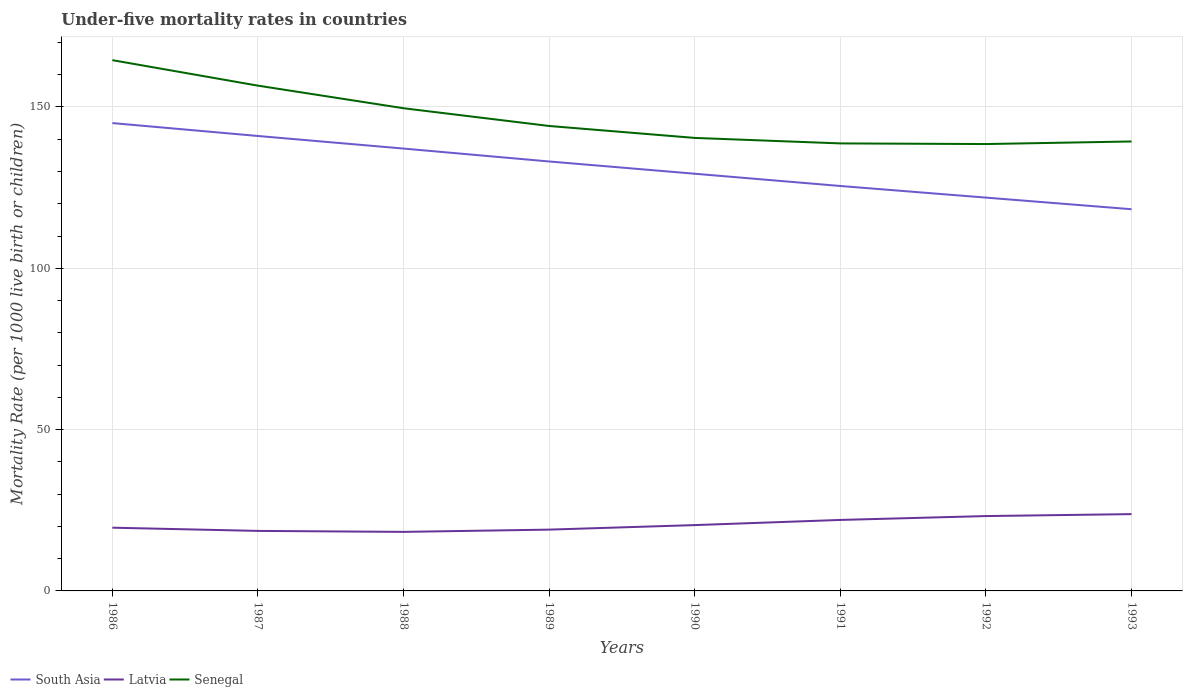How many different coloured lines are there?
Your answer should be very brief. 3. Across all years, what is the maximum under-five mortality rate in Senegal?
Offer a terse response. 138.5. In which year was the under-five mortality rate in Latvia maximum?
Your answer should be compact. 1988. What is the total under-five mortality rate in Senegal in the graph?
Offer a very short reply. 0.2. What is the difference between the highest and the second highest under-five mortality rate in South Asia?
Give a very brief answer. 26.7. How many lines are there?
Your answer should be very brief. 3. How many years are there in the graph?
Your answer should be compact. 8. What is the difference between two consecutive major ticks on the Y-axis?
Keep it short and to the point. 50. Are the values on the major ticks of Y-axis written in scientific E-notation?
Ensure brevity in your answer.  No. Does the graph contain any zero values?
Keep it short and to the point. No. Where does the legend appear in the graph?
Make the answer very short. Bottom left. What is the title of the graph?
Make the answer very short. Under-five mortality rates in countries. Does "Suriname" appear as one of the legend labels in the graph?
Your response must be concise. No. What is the label or title of the Y-axis?
Your answer should be compact. Mortality Rate (per 1000 live birth or children). What is the Mortality Rate (per 1000 live birth or children) in South Asia in 1986?
Your response must be concise. 145. What is the Mortality Rate (per 1000 live birth or children) in Latvia in 1986?
Your response must be concise. 19.6. What is the Mortality Rate (per 1000 live birth or children) in Senegal in 1986?
Keep it short and to the point. 164.5. What is the Mortality Rate (per 1000 live birth or children) of South Asia in 1987?
Keep it short and to the point. 141. What is the Mortality Rate (per 1000 live birth or children) in Latvia in 1987?
Ensure brevity in your answer.  18.6. What is the Mortality Rate (per 1000 live birth or children) of Senegal in 1987?
Offer a terse response. 156.6. What is the Mortality Rate (per 1000 live birth or children) of South Asia in 1988?
Keep it short and to the point. 137.1. What is the Mortality Rate (per 1000 live birth or children) of Latvia in 1988?
Make the answer very short. 18.3. What is the Mortality Rate (per 1000 live birth or children) in Senegal in 1988?
Offer a terse response. 149.6. What is the Mortality Rate (per 1000 live birth or children) of South Asia in 1989?
Ensure brevity in your answer.  133.1. What is the Mortality Rate (per 1000 live birth or children) of Latvia in 1989?
Keep it short and to the point. 19. What is the Mortality Rate (per 1000 live birth or children) in Senegal in 1989?
Your response must be concise. 144.1. What is the Mortality Rate (per 1000 live birth or children) of South Asia in 1990?
Offer a terse response. 129.3. What is the Mortality Rate (per 1000 live birth or children) in Latvia in 1990?
Your answer should be compact. 20.4. What is the Mortality Rate (per 1000 live birth or children) in Senegal in 1990?
Give a very brief answer. 140.4. What is the Mortality Rate (per 1000 live birth or children) in South Asia in 1991?
Your answer should be compact. 125.5. What is the Mortality Rate (per 1000 live birth or children) of Latvia in 1991?
Your answer should be compact. 22. What is the Mortality Rate (per 1000 live birth or children) in Senegal in 1991?
Keep it short and to the point. 138.7. What is the Mortality Rate (per 1000 live birth or children) of South Asia in 1992?
Provide a short and direct response. 121.9. What is the Mortality Rate (per 1000 live birth or children) in Latvia in 1992?
Your answer should be compact. 23.2. What is the Mortality Rate (per 1000 live birth or children) of Senegal in 1992?
Give a very brief answer. 138.5. What is the Mortality Rate (per 1000 live birth or children) in South Asia in 1993?
Your answer should be very brief. 118.3. What is the Mortality Rate (per 1000 live birth or children) of Latvia in 1993?
Your answer should be very brief. 23.8. What is the Mortality Rate (per 1000 live birth or children) of Senegal in 1993?
Give a very brief answer. 139.3. Across all years, what is the maximum Mortality Rate (per 1000 live birth or children) of South Asia?
Make the answer very short. 145. Across all years, what is the maximum Mortality Rate (per 1000 live birth or children) in Latvia?
Provide a short and direct response. 23.8. Across all years, what is the maximum Mortality Rate (per 1000 live birth or children) in Senegal?
Ensure brevity in your answer.  164.5. Across all years, what is the minimum Mortality Rate (per 1000 live birth or children) in South Asia?
Give a very brief answer. 118.3. Across all years, what is the minimum Mortality Rate (per 1000 live birth or children) of Senegal?
Your answer should be compact. 138.5. What is the total Mortality Rate (per 1000 live birth or children) of South Asia in the graph?
Ensure brevity in your answer.  1051.2. What is the total Mortality Rate (per 1000 live birth or children) of Latvia in the graph?
Keep it short and to the point. 164.9. What is the total Mortality Rate (per 1000 live birth or children) in Senegal in the graph?
Provide a short and direct response. 1171.7. What is the difference between the Mortality Rate (per 1000 live birth or children) of Latvia in 1986 and that in 1987?
Provide a succinct answer. 1. What is the difference between the Mortality Rate (per 1000 live birth or children) in Senegal in 1986 and that in 1988?
Provide a succinct answer. 14.9. What is the difference between the Mortality Rate (per 1000 live birth or children) of South Asia in 1986 and that in 1989?
Your response must be concise. 11.9. What is the difference between the Mortality Rate (per 1000 live birth or children) in Latvia in 1986 and that in 1989?
Ensure brevity in your answer.  0.6. What is the difference between the Mortality Rate (per 1000 live birth or children) in Senegal in 1986 and that in 1989?
Your answer should be compact. 20.4. What is the difference between the Mortality Rate (per 1000 live birth or children) of South Asia in 1986 and that in 1990?
Offer a very short reply. 15.7. What is the difference between the Mortality Rate (per 1000 live birth or children) of Senegal in 1986 and that in 1990?
Provide a short and direct response. 24.1. What is the difference between the Mortality Rate (per 1000 live birth or children) of Latvia in 1986 and that in 1991?
Give a very brief answer. -2.4. What is the difference between the Mortality Rate (per 1000 live birth or children) of Senegal in 1986 and that in 1991?
Make the answer very short. 25.8. What is the difference between the Mortality Rate (per 1000 live birth or children) in South Asia in 1986 and that in 1992?
Give a very brief answer. 23.1. What is the difference between the Mortality Rate (per 1000 live birth or children) of Latvia in 1986 and that in 1992?
Offer a very short reply. -3.6. What is the difference between the Mortality Rate (per 1000 live birth or children) in Senegal in 1986 and that in 1992?
Keep it short and to the point. 26. What is the difference between the Mortality Rate (per 1000 live birth or children) in South Asia in 1986 and that in 1993?
Your response must be concise. 26.7. What is the difference between the Mortality Rate (per 1000 live birth or children) in Senegal in 1986 and that in 1993?
Provide a succinct answer. 25.2. What is the difference between the Mortality Rate (per 1000 live birth or children) of South Asia in 1987 and that in 1988?
Keep it short and to the point. 3.9. What is the difference between the Mortality Rate (per 1000 live birth or children) in Senegal in 1987 and that in 1989?
Provide a succinct answer. 12.5. What is the difference between the Mortality Rate (per 1000 live birth or children) of Latvia in 1987 and that in 1990?
Offer a very short reply. -1.8. What is the difference between the Mortality Rate (per 1000 live birth or children) of Latvia in 1987 and that in 1991?
Your answer should be very brief. -3.4. What is the difference between the Mortality Rate (per 1000 live birth or children) of Latvia in 1987 and that in 1992?
Provide a succinct answer. -4.6. What is the difference between the Mortality Rate (per 1000 live birth or children) of South Asia in 1987 and that in 1993?
Offer a very short reply. 22.7. What is the difference between the Mortality Rate (per 1000 live birth or children) in Latvia in 1987 and that in 1993?
Provide a short and direct response. -5.2. What is the difference between the Mortality Rate (per 1000 live birth or children) of Senegal in 1987 and that in 1993?
Offer a terse response. 17.3. What is the difference between the Mortality Rate (per 1000 live birth or children) in South Asia in 1988 and that in 1989?
Offer a very short reply. 4. What is the difference between the Mortality Rate (per 1000 live birth or children) of Senegal in 1988 and that in 1989?
Offer a terse response. 5.5. What is the difference between the Mortality Rate (per 1000 live birth or children) in Latvia in 1988 and that in 1990?
Offer a very short reply. -2.1. What is the difference between the Mortality Rate (per 1000 live birth or children) of South Asia in 1988 and that in 1991?
Provide a short and direct response. 11.6. What is the difference between the Mortality Rate (per 1000 live birth or children) in Senegal in 1988 and that in 1991?
Give a very brief answer. 10.9. What is the difference between the Mortality Rate (per 1000 live birth or children) of South Asia in 1988 and that in 1992?
Offer a terse response. 15.2. What is the difference between the Mortality Rate (per 1000 live birth or children) of South Asia in 1988 and that in 1993?
Provide a short and direct response. 18.8. What is the difference between the Mortality Rate (per 1000 live birth or children) of Latvia in 1988 and that in 1993?
Make the answer very short. -5.5. What is the difference between the Mortality Rate (per 1000 live birth or children) in South Asia in 1989 and that in 1990?
Your answer should be compact. 3.8. What is the difference between the Mortality Rate (per 1000 live birth or children) in Latvia in 1989 and that in 1991?
Offer a terse response. -3. What is the difference between the Mortality Rate (per 1000 live birth or children) in Senegal in 1989 and that in 1991?
Make the answer very short. 5.4. What is the difference between the Mortality Rate (per 1000 live birth or children) in South Asia in 1989 and that in 1992?
Your answer should be compact. 11.2. What is the difference between the Mortality Rate (per 1000 live birth or children) in Senegal in 1989 and that in 1992?
Provide a succinct answer. 5.6. What is the difference between the Mortality Rate (per 1000 live birth or children) of Latvia in 1989 and that in 1993?
Provide a short and direct response. -4.8. What is the difference between the Mortality Rate (per 1000 live birth or children) of Senegal in 1989 and that in 1993?
Give a very brief answer. 4.8. What is the difference between the Mortality Rate (per 1000 live birth or children) of Latvia in 1990 and that in 1991?
Offer a very short reply. -1.6. What is the difference between the Mortality Rate (per 1000 live birth or children) in Senegal in 1990 and that in 1991?
Offer a terse response. 1.7. What is the difference between the Mortality Rate (per 1000 live birth or children) of Latvia in 1990 and that in 1992?
Your answer should be compact. -2.8. What is the difference between the Mortality Rate (per 1000 live birth or children) in Senegal in 1990 and that in 1992?
Your answer should be very brief. 1.9. What is the difference between the Mortality Rate (per 1000 live birth or children) in South Asia in 1990 and that in 1993?
Ensure brevity in your answer.  11. What is the difference between the Mortality Rate (per 1000 live birth or children) of Senegal in 1990 and that in 1993?
Your answer should be compact. 1.1. What is the difference between the Mortality Rate (per 1000 live birth or children) in South Asia in 1991 and that in 1993?
Your answer should be compact. 7.2. What is the difference between the Mortality Rate (per 1000 live birth or children) in Senegal in 1991 and that in 1993?
Provide a short and direct response. -0.6. What is the difference between the Mortality Rate (per 1000 live birth or children) in South Asia in 1992 and that in 1993?
Offer a very short reply. 3.6. What is the difference between the Mortality Rate (per 1000 live birth or children) of Latvia in 1992 and that in 1993?
Your answer should be very brief. -0.6. What is the difference between the Mortality Rate (per 1000 live birth or children) of Senegal in 1992 and that in 1993?
Offer a terse response. -0.8. What is the difference between the Mortality Rate (per 1000 live birth or children) of South Asia in 1986 and the Mortality Rate (per 1000 live birth or children) of Latvia in 1987?
Provide a short and direct response. 126.4. What is the difference between the Mortality Rate (per 1000 live birth or children) of Latvia in 1986 and the Mortality Rate (per 1000 live birth or children) of Senegal in 1987?
Offer a very short reply. -137. What is the difference between the Mortality Rate (per 1000 live birth or children) of South Asia in 1986 and the Mortality Rate (per 1000 live birth or children) of Latvia in 1988?
Offer a terse response. 126.7. What is the difference between the Mortality Rate (per 1000 live birth or children) of South Asia in 1986 and the Mortality Rate (per 1000 live birth or children) of Senegal in 1988?
Ensure brevity in your answer.  -4.6. What is the difference between the Mortality Rate (per 1000 live birth or children) of Latvia in 1986 and the Mortality Rate (per 1000 live birth or children) of Senegal in 1988?
Offer a very short reply. -130. What is the difference between the Mortality Rate (per 1000 live birth or children) of South Asia in 1986 and the Mortality Rate (per 1000 live birth or children) of Latvia in 1989?
Offer a terse response. 126. What is the difference between the Mortality Rate (per 1000 live birth or children) in South Asia in 1986 and the Mortality Rate (per 1000 live birth or children) in Senegal in 1989?
Offer a very short reply. 0.9. What is the difference between the Mortality Rate (per 1000 live birth or children) in Latvia in 1986 and the Mortality Rate (per 1000 live birth or children) in Senegal in 1989?
Give a very brief answer. -124.5. What is the difference between the Mortality Rate (per 1000 live birth or children) of South Asia in 1986 and the Mortality Rate (per 1000 live birth or children) of Latvia in 1990?
Give a very brief answer. 124.6. What is the difference between the Mortality Rate (per 1000 live birth or children) in Latvia in 1986 and the Mortality Rate (per 1000 live birth or children) in Senegal in 1990?
Make the answer very short. -120.8. What is the difference between the Mortality Rate (per 1000 live birth or children) of South Asia in 1986 and the Mortality Rate (per 1000 live birth or children) of Latvia in 1991?
Keep it short and to the point. 123. What is the difference between the Mortality Rate (per 1000 live birth or children) in Latvia in 1986 and the Mortality Rate (per 1000 live birth or children) in Senegal in 1991?
Keep it short and to the point. -119.1. What is the difference between the Mortality Rate (per 1000 live birth or children) of South Asia in 1986 and the Mortality Rate (per 1000 live birth or children) of Latvia in 1992?
Make the answer very short. 121.8. What is the difference between the Mortality Rate (per 1000 live birth or children) in Latvia in 1986 and the Mortality Rate (per 1000 live birth or children) in Senegal in 1992?
Make the answer very short. -118.9. What is the difference between the Mortality Rate (per 1000 live birth or children) in South Asia in 1986 and the Mortality Rate (per 1000 live birth or children) in Latvia in 1993?
Provide a short and direct response. 121.2. What is the difference between the Mortality Rate (per 1000 live birth or children) of Latvia in 1986 and the Mortality Rate (per 1000 live birth or children) of Senegal in 1993?
Your response must be concise. -119.7. What is the difference between the Mortality Rate (per 1000 live birth or children) of South Asia in 1987 and the Mortality Rate (per 1000 live birth or children) of Latvia in 1988?
Provide a succinct answer. 122.7. What is the difference between the Mortality Rate (per 1000 live birth or children) in Latvia in 1987 and the Mortality Rate (per 1000 live birth or children) in Senegal in 1988?
Offer a terse response. -131. What is the difference between the Mortality Rate (per 1000 live birth or children) in South Asia in 1987 and the Mortality Rate (per 1000 live birth or children) in Latvia in 1989?
Give a very brief answer. 122. What is the difference between the Mortality Rate (per 1000 live birth or children) of South Asia in 1987 and the Mortality Rate (per 1000 live birth or children) of Senegal in 1989?
Your answer should be compact. -3.1. What is the difference between the Mortality Rate (per 1000 live birth or children) in Latvia in 1987 and the Mortality Rate (per 1000 live birth or children) in Senegal in 1989?
Provide a short and direct response. -125.5. What is the difference between the Mortality Rate (per 1000 live birth or children) in South Asia in 1987 and the Mortality Rate (per 1000 live birth or children) in Latvia in 1990?
Offer a terse response. 120.6. What is the difference between the Mortality Rate (per 1000 live birth or children) of South Asia in 1987 and the Mortality Rate (per 1000 live birth or children) of Senegal in 1990?
Your response must be concise. 0.6. What is the difference between the Mortality Rate (per 1000 live birth or children) of Latvia in 1987 and the Mortality Rate (per 1000 live birth or children) of Senegal in 1990?
Your response must be concise. -121.8. What is the difference between the Mortality Rate (per 1000 live birth or children) of South Asia in 1987 and the Mortality Rate (per 1000 live birth or children) of Latvia in 1991?
Offer a terse response. 119. What is the difference between the Mortality Rate (per 1000 live birth or children) of Latvia in 1987 and the Mortality Rate (per 1000 live birth or children) of Senegal in 1991?
Offer a terse response. -120.1. What is the difference between the Mortality Rate (per 1000 live birth or children) in South Asia in 1987 and the Mortality Rate (per 1000 live birth or children) in Latvia in 1992?
Offer a terse response. 117.8. What is the difference between the Mortality Rate (per 1000 live birth or children) in South Asia in 1987 and the Mortality Rate (per 1000 live birth or children) in Senegal in 1992?
Give a very brief answer. 2.5. What is the difference between the Mortality Rate (per 1000 live birth or children) of Latvia in 1987 and the Mortality Rate (per 1000 live birth or children) of Senegal in 1992?
Provide a short and direct response. -119.9. What is the difference between the Mortality Rate (per 1000 live birth or children) of South Asia in 1987 and the Mortality Rate (per 1000 live birth or children) of Latvia in 1993?
Offer a terse response. 117.2. What is the difference between the Mortality Rate (per 1000 live birth or children) in South Asia in 1987 and the Mortality Rate (per 1000 live birth or children) in Senegal in 1993?
Make the answer very short. 1.7. What is the difference between the Mortality Rate (per 1000 live birth or children) in Latvia in 1987 and the Mortality Rate (per 1000 live birth or children) in Senegal in 1993?
Provide a short and direct response. -120.7. What is the difference between the Mortality Rate (per 1000 live birth or children) in South Asia in 1988 and the Mortality Rate (per 1000 live birth or children) in Latvia in 1989?
Make the answer very short. 118.1. What is the difference between the Mortality Rate (per 1000 live birth or children) of South Asia in 1988 and the Mortality Rate (per 1000 live birth or children) of Senegal in 1989?
Make the answer very short. -7. What is the difference between the Mortality Rate (per 1000 live birth or children) of Latvia in 1988 and the Mortality Rate (per 1000 live birth or children) of Senegal in 1989?
Provide a short and direct response. -125.8. What is the difference between the Mortality Rate (per 1000 live birth or children) of South Asia in 1988 and the Mortality Rate (per 1000 live birth or children) of Latvia in 1990?
Give a very brief answer. 116.7. What is the difference between the Mortality Rate (per 1000 live birth or children) in South Asia in 1988 and the Mortality Rate (per 1000 live birth or children) in Senegal in 1990?
Your answer should be very brief. -3.3. What is the difference between the Mortality Rate (per 1000 live birth or children) in Latvia in 1988 and the Mortality Rate (per 1000 live birth or children) in Senegal in 1990?
Make the answer very short. -122.1. What is the difference between the Mortality Rate (per 1000 live birth or children) in South Asia in 1988 and the Mortality Rate (per 1000 live birth or children) in Latvia in 1991?
Your answer should be compact. 115.1. What is the difference between the Mortality Rate (per 1000 live birth or children) of South Asia in 1988 and the Mortality Rate (per 1000 live birth or children) of Senegal in 1991?
Keep it short and to the point. -1.6. What is the difference between the Mortality Rate (per 1000 live birth or children) of Latvia in 1988 and the Mortality Rate (per 1000 live birth or children) of Senegal in 1991?
Provide a short and direct response. -120.4. What is the difference between the Mortality Rate (per 1000 live birth or children) in South Asia in 1988 and the Mortality Rate (per 1000 live birth or children) in Latvia in 1992?
Make the answer very short. 113.9. What is the difference between the Mortality Rate (per 1000 live birth or children) of Latvia in 1988 and the Mortality Rate (per 1000 live birth or children) of Senegal in 1992?
Provide a short and direct response. -120.2. What is the difference between the Mortality Rate (per 1000 live birth or children) in South Asia in 1988 and the Mortality Rate (per 1000 live birth or children) in Latvia in 1993?
Your answer should be very brief. 113.3. What is the difference between the Mortality Rate (per 1000 live birth or children) of South Asia in 1988 and the Mortality Rate (per 1000 live birth or children) of Senegal in 1993?
Keep it short and to the point. -2.2. What is the difference between the Mortality Rate (per 1000 live birth or children) in Latvia in 1988 and the Mortality Rate (per 1000 live birth or children) in Senegal in 1993?
Make the answer very short. -121. What is the difference between the Mortality Rate (per 1000 live birth or children) in South Asia in 1989 and the Mortality Rate (per 1000 live birth or children) in Latvia in 1990?
Your answer should be very brief. 112.7. What is the difference between the Mortality Rate (per 1000 live birth or children) in South Asia in 1989 and the Mortality Rate (per 1000 live birth or children) in Senegal in 1990?
Give a very brief answer. -7.3. What is the difference between the Mortality Rate (per 1000 live birth or children) in Latvia in 1989 and the Mortality Rate (per 1000 live birth or children) in Senegal in 1990?
Provide a succinct answer. -121.4. What is the difference between the Mortality Rate (per 1000 live birth or children) of South Asia in 1989 and the Mortality Rate (per 1000 live birth or children) of Latvia in 1991?
Provide a short and direct response. 111.1. What is the difference between the Mortality Rate (per 1000 live birth or children) in South Asia in 1989 and the Mortality Rate (per 1000 live birth or children) in Senegal in 1991?
Make the answer very short. -5.6. What is the difference between the Mortality Rate (per 1000 live birth or children) in Latvia in 1989 and the Mortality Rate (per 1000 live birth or children) in Senegal in 1991?
Give a very brief answer. -119.7. What is the difference between the Mortality Rate (per 1000 live birth or children) of South Asia in 1989 and the Mortality Rate (per 1000 live birth or children) of Latvia in 1992?
Ensure brevity in your answer.  109.9. What is the difference between the Mortality Rate (per 1000 live birth or children) of Latvia in 1989 and the Mortality Rate (per 1000 live birth or children) of Senegal in 1992?
Make the answer very short. -119.5. What is the difference between the Mortality Rate (per 1000 live birth or children) of South Asia in 1989 and the Mortality Rate (per 1000 live birth or children) of Latvia in 1993?
Keep it short and to the point. 109.3. What is the difference between the Mortality Rate (per 1000 live birth or children) in Latvia in 1989 and the Mortality Rate (per 1000 live birth or children) in Senegal in 1993?
Your response must be concise. -120.3. What is the difference between the Mortality Rate (per 1000 live birth or children) in South Asia in 1990 and the Mortality Rate (per 1000 live birth or children) in Latvia in 1991?
Give a very brief answer. 107.3. What is the difference between the Mortality Rate (per 1000 live birth or children) in Latvia in 1990 and the Mortality Rate (per 1000 live birth or children) in Senegal in 1991?
Make the answer very short. -118.3. What is the difference between the Mortality Rate (per 1000 live birth or children) of South Asia in 1990 and the Mortality Rate (per 1000 live birth or children) of Latvia in 1992?
Your answer should be compact. 106.1. What is the difference between the Mortality Rate (per 1000 live birth or children) of Latvia in 1990 and the Mortality Rate (per 1000 live birth or children) of Senegal in 1992?
Your response must be concise. -118.1. What is the difference between the Mortality Rate (per 1000 live birth or children) of South Asia in 1990 and the Mortality Rate (per 1000 live birth or children) of Latvia in 1993?
Your response must be concise. 105.5. What is the difference between the Mortality Rate (per 1000 live birth or children) of Latvia in 1990 and the Mortality Rate (per 1000 live birth or children) of Senegal in 1993?
Ensure brevity in your answer.  -118.9. What is the difference between the Mortality Rate (per 1000 live birth or children) in South Asia in 1991 and the Mortality Rate (per 1000 live birth or children) in Latvia in 1992?
Provide a succinct answer. 102.3. What is the difference between the Mortality Rate (per 1000 live birth or children) in Latvia in 1991 and the Mortality Rate (per 1000 live birth or children) in Senegal in 1992?
Your response must be concise. -116.5. What is the difference between the Mortality Rate (per 1000 live birth or children) in South Asia in 1991 and the Mortality Rate (per 1000 live birth or children) in Latvia in 1993?
Make the answer very short. 101.7. What is the difference between the Mortality Rate (per 1000 live birth or children) of Latvia in 1991 and the Mortality Rate (per 1000 live birth or children) of Senegal in 1993?
Give a very brief answer. -117.3. What is the difference between the Mortality Rate (per 1000 live birth or children) of South Asia in 1992 and the Mortality Rate (per 1000 live birth or children) of Latvia in 1993?
Give a very brief answer. 98.1. What is the difference between the Mortality Rate (per 1000 live birth or children) of South Asia in 1992 and the Mortality Rate (per 1000 live birth or children) of Senegal in 1993?
Offer a terse response. -17.4. What is the difference between the Mortality Rate (per 1000 live birth or children) of Latvia in 1992 and the Mortality Rate (per 1000 live birth or children) of Senegal in 1993?
Offer a very short reply. -116.1. What is the average Mortality Rate (per 1000 live birth or children) in South Asia per year?
Give a very brief answer. 131.4. What is the average Mortality Rate (per 1000 live birth or children) of Latvia per year?
Keep it short and to the point. 20.61. What is the average Mortality Rate (per 1000 live birth or children) of Senegal per year?
Your answer should be very brief. 146.46. In the year 1986, what is the difference between the Mortality Rate (per 1000 live birth or children) of South Asia and Mortality Rate (per 1000 live birth or children) of Latvia?
Offer a very short reply. 125.4. In the year 1986, what is the difference between the Mortality Rate (per 1000 live birth or children) of South Asia and Mortality Rate (per 1000 live birth or children) of Senegal?
Your answer should be very brief. -19.5. In the year 1986, what is the difference between the Mortality Rate (per 1000 live birth or children) in Latvia and Mortality Rate (per 1000 live birth or children) in Senegal?
Make the answer very short. -144.9. In the year 1987, what is the difference between the Mortality Rate (per 1000 live birth or children) in South Asia and Mortality Rate (per 1000 live birth or children) in Latvia?
Your answer should be very brief. 122.4. In the year 1987, what is the difference between the Mortality Rate (per 1000 live birth or children) in South Asia and Mortality Rate (per 1000 live birth or children) in Senegal?
Your response must be concise. -15.6. In the year 1987, what is the difference between the Mortality Rate (per 1000 live birth or children) of Latvia and Mortality Rate (per 1000 live birth or children) of Senegal?
Ensure brevity in your answer.  -138. In the year 1988, what is the difference between the Mortality Rate (per 1000 live birth or children) of South Asia and Mortality Rate (per 1000 live birth or children) of Latvia?
Provide a succinct answer. 118.8. In the year 1988, what is the difference between the Mortality Rate (per 1000 live birth or children) of Latvia and Mortality Rate (per 1000 live birth or children) of Senegal?
Provide a short and direct response. -131.3. In the year 1989, what is the difference between the Mortality Rate (per 1000 live birth or children) of South Asia and Mortality Rate (per 1000 live birth or children) of Latvia?
Make the answer very short. 114.1. In the year 1989, what is the difference between the Mortality Rate (per 1000 live birth or children) in South Asia and Mortality Rate (per 1000 live birth or children) in Senegal?
Offer a terse response. -11. In the year 1989, what is the difference between the Mortality Rate (per 1000 live birth or children) of Latvia and Mortality Rate (per 1000 live birth or children) of Senegal?
Provide a succinct answer. -125.1. In the year 1990, what is the difference between the Mortality Rate (per 1000 live birth or children) of South Asia and Mortality Rate (per 1000 live birth or children) of Latvia?
Provide a short and direct response. 108.9. In the year 1990, what is the difference between the Mortality Rate (per 1000 live birth or children) in South Asia and Mortality Rate (per 1000 live birth or children) in Senegal?
Your response must be concise. -11.1. In the year 1990, what is the difference between the Mortality Rate (per 1000 live birth or children) of Latvia and Mortality Rate (per 1000 live birth or children) of Senegal?
Give a very brief answer. -120. In the year 1991, what is the difference between the Mortality Rate (per 1000 live birth or children) of South Asia and Mortality Rate (per 1000 live birth or children) of Latvia?
Ensure brevity in your answer.  103.5. In the year 1991, what is the difference between the Mortality Rate (per 1000 live birth or children) of South Asia and Mortality Rate (per 1000 live birth or children) of Senegal?
Give a very brief answer. -13.2. In the year 1991, what is the difference between the Mortality Rate (per 1000 live birth or children) in Latvia and Mortality Rate (per 1000 live birth or children) in Senegal?
Ensure brevity in your answer.  -116.7. In the year 1992, what is the difference between the Mortality Rate (per 1000 live birth or children) in South Asia and Mortality Rate (per 1000 live birth or children) in Latvia?
Ensure brevity in your answer.  98.7. In the year 1992, what is the difference between the Mortality Rate (per 1000 live birth or children) in South Asia and Mortality Rate (per 1000 live birth or children) in Senegal?
Your response must be concise. -16.6. In the year 1992, what is the difference between the Mortality Rate (per 1000 live birth or children) in Latvia and Mortality Rate (per 1000 live birth or children) in Senegal?
Your answer should be compact. -115.3. In the year 1993, what is the difference between the Mortality Rate (per 1000 live birth or children) of South Asia and Mortality Rate (per 1000 live birth or children) of Latvia?
Offer a terse response. 94.5. In the year 1993, what is the difference between the Mortality Rate (per 1000 live birth or children) of South Asia and Mortality Rate (per 1000 live birth or children) of Senegal?
Offer a very short reply. -21. In the year 1993, what is the difference between the Mortality Rate (per 1000 live birth or children) in Latvia and Mortality Rate (per 1000 live birth or children) in Senegal?
Offer a terse response. -115.5. What is the ratio of the Mortality Rate (per 1000 live birth or children) in South Asia in 1986 to that in 1987?
Ensure brevity in your answer.  1.03. What is the ratio of the Mortality Rate (per 1000 live birth or children) of Latvia in 1986 to that in 1987?
Your answer should be very brief. 1.05. What is the ratio of the Mortality Rate (per 1000 live birth or children) in Senegal in 1986 to that in 1987?
Provide a short and direct response. 1.05. What is the ratio of the Mortality Rate (per 1000 live birth or children) in South Asia in 1986 to that in 1988?
Keep it short and to the point. 1.06. What is the ratio of the Mortality Rate (per 1000 live birth or children) of Latvia in 1986 to that in 1988?
Keep it short and to the point. 1.07. What is the ratio of the Mortality Rate (per 1000 live birth or children) of Senegal in 1986 to that in 1988?
Give a very brief answer. 1.1. What is the ratio of the Mortality Rate (per 1000 live birth or children) of South Asia in 1986 to that in 1989?
Your response must be concise. 1.09. What is the ratio of the Mortality Rate (per 1000 live birth or children) of Latvia in 1986 to that in 1989?
Your answer should be compact. 1.03. What is the ratio of the Mortality Rate (per 1000 live birth or children) of Senegal in 1986 to that in 1989?
Offer a terse response. 1.14. What is the ratio of the Mortality Rate (per 1000 live birth or children) in South Asia in 1986 to that in 1990?
Your answer should be very brief. 1.12. What is the ratio of the Mortality Rate (per 1000 live birth or children) of Latvia in 1986 to that in 1990?
Your answer should be compact. 0.96. What is the ratio of the Mortality Rate (per 1000 live birth or children) of Senegal in 1986 to that in 1990?
Your answer should be compact. 1.17. What is the ratio of the Mortality Rate (per 1000 live birth or children) of South Asia in 1986 to that in 1991?
Provide a short and direct response. 1.16. What is the ratio of the Mortality Rate (per 1000 live birth or children) in Latvia in 1986 to that in 1991?
Make the answer very short. 0.89. What is the ratio of the Mortality Rate (per 1000 live birth or children) in Senegal in 1986 to that in 1991?
Your answer should be compact. 1.19. What is the ratio of the Mortality Rate (per 1000 live birth or children) of South Asia in 1986 to that in 1992?
Your answer should be compact. 1.19. What is the ratio of the Mortality Rate (per 1000 live birth or children) in Latvia in 1986 to that in 1992?
Offer a terse response. 0.84. What is the ratio of the Mortality Rate (per 1000 live birth or children) of Senegal in 1986 to that in 1992?
Provide a short and direct response. 1.19. What is the ratio of the Mortality Rate (per 1000 live birth or children) of South Asia in 1986 to that in 1993?
Give a very brief answer. 1.23. What is the ratio of the Mortality Rate (per 1000 live birth or children) in Latvia in 1986 to that in 1993?
Your response must be concise. 0.82. What is the ratio of the Mortality Rate (per 1000 live birth or children) of Senegal in 1986 to that in 1993?
Keep it short and to the point. 1.18. What is the ratio of the Mortality Rate (per 1000 live birth or children) of South Asia in 1987 to that in 1988?
Offer a very short reply. 1.03. What is the ratio of the Mortality Rate (per 1000 live birth or children) in Latvia in 1987 to that in 1988?
Your response must be concise. 1.02. What is the ratio of the Mortality Rate (per 1000 live birth or children) of Senegal in 1987 to that in 1988?
Your answer should be very brief. 1.05. What is the ratio of the Mortality Rate (per 1000 live birth or children) in South Asia in 1987 to that in 1989?
Offer a very short reply. 1.06. What is the ratio of the Mortality Rate (per 1000 live birth or children) in Latvia in 1987 to that in 1989?
Provide a succinct answer. 0.98. What is the ratio of the Mortality Rate (per 1000 live birth or children) in Senegal in 1987 to that in 1989?
Give a very brief answer. 1.09. What is the ratio of the Mortality Rate (per 1000 live birth or children) of South Asia in 1987 to that in 1990?
Keep it short and to the point. 1.09. What is the ratio of the Mortality Rate (per 1000 live birth or children) in Latvia in 1987 to that in 1990?
Make the answer very short. 0.91. What is the ratio of the Mortality Rate (per 1000 live birth or children) of Senegal in 1987 to that in 1990?
Ensure brevity in your answer.  1.12. What is the ratio of the Mortality Rate (per 1000 live birth or children) of South Asia in 1987 to that in 1991?
Offer a very short reply. 1.12. What is the ratio of the Mortality Rate (per 1000 live birth or children) in Latvia in 1987 to that in 1991?
Make the answer very short. 0.85. What is the ratio of the Mortality Rate (per 1000 live birth or children) in Senegal in 1987 to that in 1991?
Give a very brief answer. 1.13. What is the ratio of the Mortality Rate (per 1000 live birth or children) of South Asia in 1987 to that in 1992?
Your response must be concise. 1.16. What is the ratio of the Mortality Rate (per 1000 live birth or children) in Latvia in 1987 to that in 1992?
Keep it short and to the point. 0.8. What is the ratio of the Mortality Rate (per 1000 live birth or children) of Senegal in 1987 to that in 1992?
Your answer should be compact. 1.13. What is the ratio of the Mortality Rate (per 1000 live birth or children) of South Asia in 1987 to that in 1993?
Ensure brevity in your answer.  1.19. What is the ratio of the Mortality Rate (per 1000 live birth or children) of Latvia in 1987 to that in 1993?
Give a very brief answer. 0.78. What is the ratio of the Mortality Rate (per 1000 live birth or children) in Senegal in 1987 to that in 1993?
Provide a succinct answer. 1.12. What is the ratio of the Mortality Rate (per 1000 live birth or children) in South Asia in 1988 to that in 1989?
Give a very brief answer. 1.03. What is the ratio of the Mortality Rate (per 1000 live birth or children) in Latvia in 1988 to that in 1989?
Offer a very short reply. 0.96. What is the ratio of the Mortality Rate (per 1000 live birth or children) of Senegal in 1988 to that in 1989?
Your answer should be compact. 1.04. What is the ratio of the Mortality Rate (per 1000 live birth or children) in South Asia in 1988 to that in 1990?
Your answer should be compact. 1.06. What is the ratio of the Mortality Rate (per 1000 live birth or children) in Latvia in 1988 to that in 1990?
Keep it short and to the point. 0.9. What is the ratio of the Mortality Rate (per 1000 live birth or children) of Senegal in 1988 to that in 1990?
Provide a succinct answer. 1.07. What is the ratio of the Mortality Rate (per 1000 live birth or children) of South Asia in 1988 to that in 1991?
Offer a terse response. 1.09. What is the ratio of the Mortality Rate (per 1000 live birth or children) in Latvia in 1988 to that in 1991?
Keep it short and to the point. 0.83. What is the ratio of the Mortality Rate (per 1000 live birth or children) of Senegal in 1988 to that in 1991?
Your answer should be compact. 1.08. What is the ratio of the Mortality Rate (per 1000 live birth or children) of South Asia in 1988 to that in 1992?
Give a very brief answer. 1.12. What is the ratio of the Mortality Rate (per 1000 live birth or children) in Latvia in 1988 to that in 1992?
Provide a short and direct response. 0.79. What is the ratio of the Mortality Rate (per 1000 live birth or children) of Senegal in 1988 to that in 1992?
Ensure brevity in your answer.  1.08. What is the ratio of the Mortality Rate (per 1000 live birth or children) in South Asia in 1988 to that in 1993?
Offer a very short reply. 1.16. What is the ratio of the Mortality Rate (per 1000 live birth or children) in Latvia in 1988 to that in 1993?
Give a very brief answer. 0.77. What is the ratio of the Mortality Rate (per 1000 live birth or children) in Senegal in 1988 to that in 1993?
Your answer should be compact. 1.07. What is the ratio of the Mortality Rate (per 1000 live birth or children) of South Asia in 1989 to that in 1990?
Provide a succinct answer. 1.03. What is the ratio of the Mortality Rate (per 1000 live birth or children) of Latvia in 1989 to that in 1990?
Your response must be concise. 0.93. What is the ratio of the Mortality Rate (per 1000 live birth or children) of Senegal in 1989 to that in 1990?
Make the answer very short. 1.03. What is the ratio of the Mortality Rate (per 1000 live birth or children) of South Asia in 1989 to that in 1991?
Give a very brief answer. 1.06. What is the ratio of the Mortality Rate (per 1000 live birth or children) of Latvia in 1989 to that in 1991?
Make the answer very short. 0.86. What is the ratio of the Mortality Rate (per 1000 live birth or children) in Senegal in 1989 to that in 1991?
Offer a terse response. 1.04. What is the ratio of the Mortality Rate (per 1000 live birth or children) of South Asia in 1989 to that in 1992?
Your answer should be very brief. 1.09. What is the ratio of the Mortality Rate (per 1000 live birth or children) of Latvia in 1989 to that in 1992?
Keep it short and to the point. 0.82. What is the ratio of the Mortality Rate (per 1000 live birth or children) of Senegal in 1989 to that in 1992?
Your answer should be very brief. 1.04. What is the ratio of the Mortality Rate (per 1000 live birth or children) in South Asia in 1989 to that in 1993?
Provide a short and direct response. 1.13. What is the ratio of the Mortality Rate (per 1000 live birth or children) of Latvia in 1989 to that in 1993?
Your answer should be very brief. 0.8. What is the ratio of the Mortality Rate (per 1000 live birth or children) of Senegal in 1989 to that in 1993?
Give a very brief answer. 1.03. What is the ratio of the Mortality Rate (per 1000 live birth or children) in South Asia in 1990 to that in 1991?
Make the answer very short. 1.03. What is the ratio of the Mortality Rate (per 1000 live birth or children) in Latvia in 1990 to that in 1991?
Your response must be concise. 0.93. What is the ratio of the Mortality Rate (per 1000 live birth or children) in Senegal in 1990 to that in 1991?
Keep it short and to the point. 1.01. What is the ratio of the Mortality Rate (per 1000 live birth or children) in South Asia in 1990 to that in 1992?
Ensure brevity in your answer.  1.06. What is the ratio of the Mortality Rate (per 1000 live birth or children) of Latvia in 1990 to that in 1992?
Ensure brevity in your answer.  0.88. What is the ratio of the Mortality Rate (per 1000 live birth or children) in Senegal in 1990 to that in 1992?
Offer a very short reply. 1.01. What is the ratio of the Mortality Rate (per 1000 live birth or children) in South Asia in 1990 to that in 1993?
Give a very brief answer. 1.09. What is the ratio of the Mortality Rate (per 1000 live birth or children) in Senegal in 1990 to that in 1993?
Ensure brevity in your answer.  1.01. What is the ratio of the Mortality Rate (per 1000 live birth or children) in South Asia in 1991 to that in 1992?
Make the answer very short. 1.03. What is the ratio of the Mortality Rate (per 1000 live birth or children) of Latvia in 1991 to that in 1992?
Your response must be concise. 0.95. What is the ratio of the Mortality Rate (per 1000 live birth or children) in Senegal in 1991 to that in 1992?
Provide a short and direct response. 1. What is the ratio of the Mortality Rate (per 1000 live birth or children) of South Asia in 1991 to that in 1993?
Make the answer very short. 1.06. What is the ratio of the Mortality Rate (per 1000 live birth or children) in Latvia in 1991 to that in 1993?
Your answer should be very brief. 0.92. What is the ratio of the Mortality Rate (per 1000 live birth or children) of Senegal in 1991 to that in 1993?
Ensure brevity in your answer.  1. What is the ratio of the Mortality Rate (per 1000 live birth or children) of South Asia in 1992 to that in 1993?
Your response must be concise. 1.03. What is the ratio of the Mortality Rate (per 1000 live birth or children) in Latvia in 1992 to that in 1993?
Keep it short and to the point. 0.97. What is the difference between the highest and the second highest Mortality Rate (per 1000 live birth or children) of South Asia?
Provide a succinct answer. 4. What is the difference between the highest and the second highest Mortality Rate (per 1000 live birth or children) of Senegal?
Provide a succinct answer. 7.9. What is the difference between the highest and the lowest Mortality Rate (per 1000 live birth or children) in South Asia?
Your answer should be very brief. 26.7. 